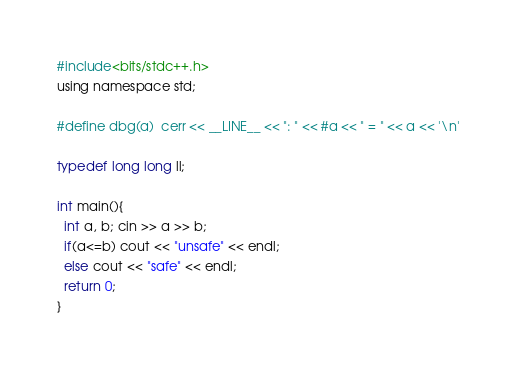Convert code to text. <code><loc_0><loc_0><loc_500><loc_500><_C_>#include<bits/stdc++.h>
using namespace std;

#define dbg(a)  cerr << __LINE__ << ": " << #a << " = " << a << '\n'

typedef long long ll;

int main(){
  int a, b; cin >> a >> b;
  if(a<=b) cout << "unsafe" << endl;
  else cout << "safe" << endl;
  return 0;
}</code> 